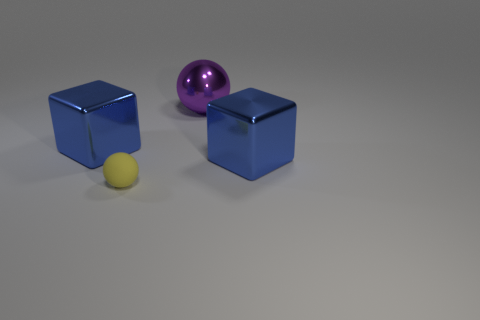Add 2 large brown objects. How many objects exist? 6 Subtract 0 green cubes. How many objects are left? 4 Subtract all purple matte spheres. Subtract all large blue metallic blocks. How many objects are left? 2 Add 2 tiny spheres. How many tiny spheres are left? 3 Add 2 small gray matte things. How many small gray matte things exist? 2 